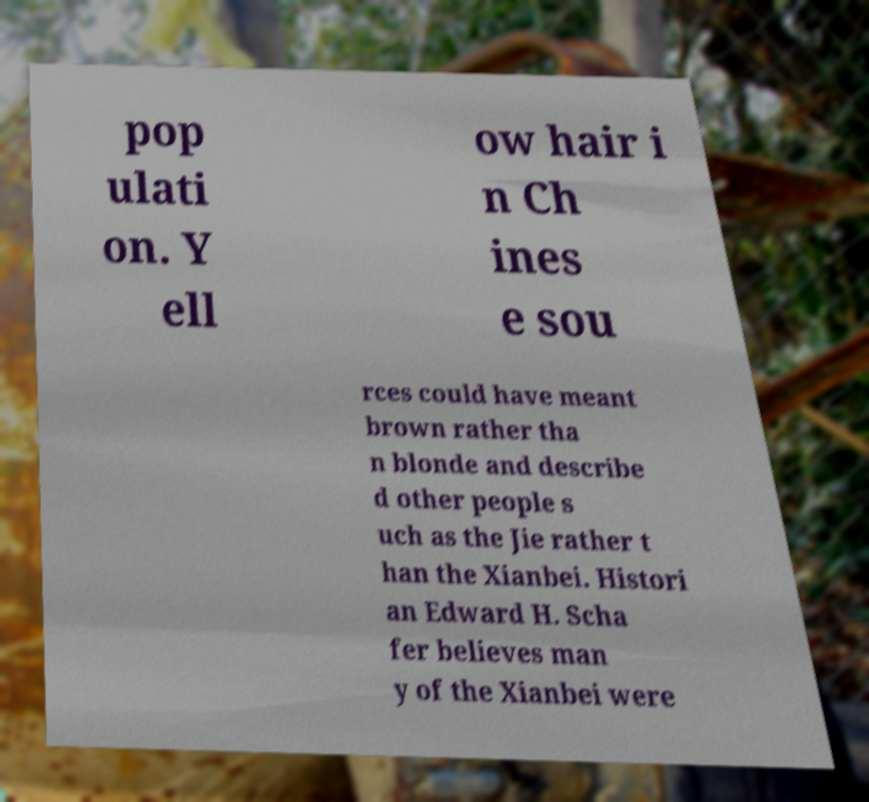Can you accurately transcribe the text from the provided image for me? pop ulati on. Y ell ow hair i n Ch ines e sou rces could have meant brown rather tha n blonde and describe d other people s uch as the Jie rather t han the Xianbei. Histori an Edward H. Scha fer believes man y of the Xianbei were 